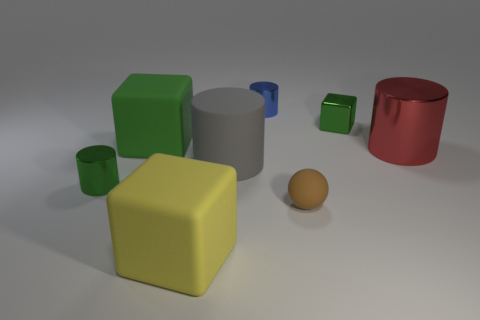Are there any tiny metallic objects that have the same color as the shiny block?
Keep it short and to the point. Yes. How many large things are red cylinders or rubber things?
Your answer should be compact. 4. How many tiny blue cylinders are there?
Provide a succinct answer. 1. There is a big cylinder to the left of the tiny blue metal cylinder; what is it made of?
Your answer should be very brief. Rubber. There is a yellow block; are there any tiny green shiny objects to the left of it?
Your answer should be compact. Yes. Is the size of the green metal cylinder the same as the red cylinder?
Offer a very short reply. No. What number of small green things have the same material as the small green cube?
Make the answer very short. 1. There is a blue shiny object that is right of the small object left of the small blue object; what is its size?
Offer a terse response. Small. The metallic thing that is both behind the gray rubber object and in front of the green shiny block is what color?
Offer a terse response. Red. Does the large red object have the same shape as the yellow thing?
Your answer should be compact. No. 